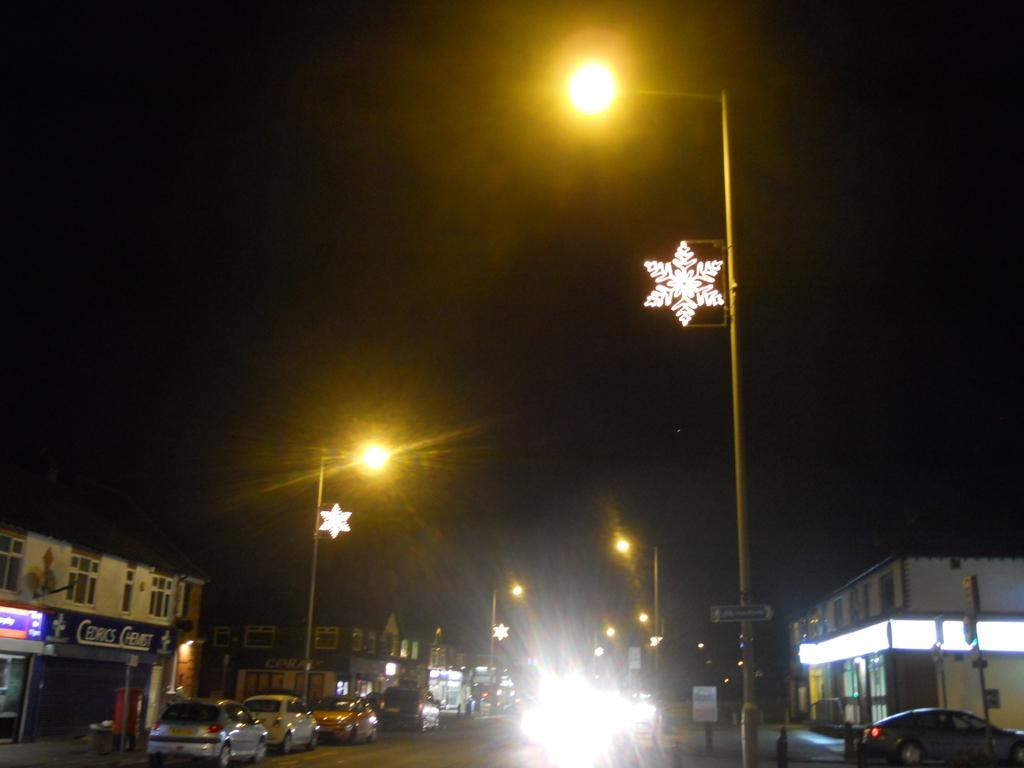What can be seen on the path in the image? There are vehicles and lights on the path in the image. What is attached to the poles in the image? There are boards on the poles in the image. What is visible in the background of the image? There are houses in the background of the image. Can you see any lizards playing a game of stocking in the image? There are no lizards or any game of stocking present in the image. 